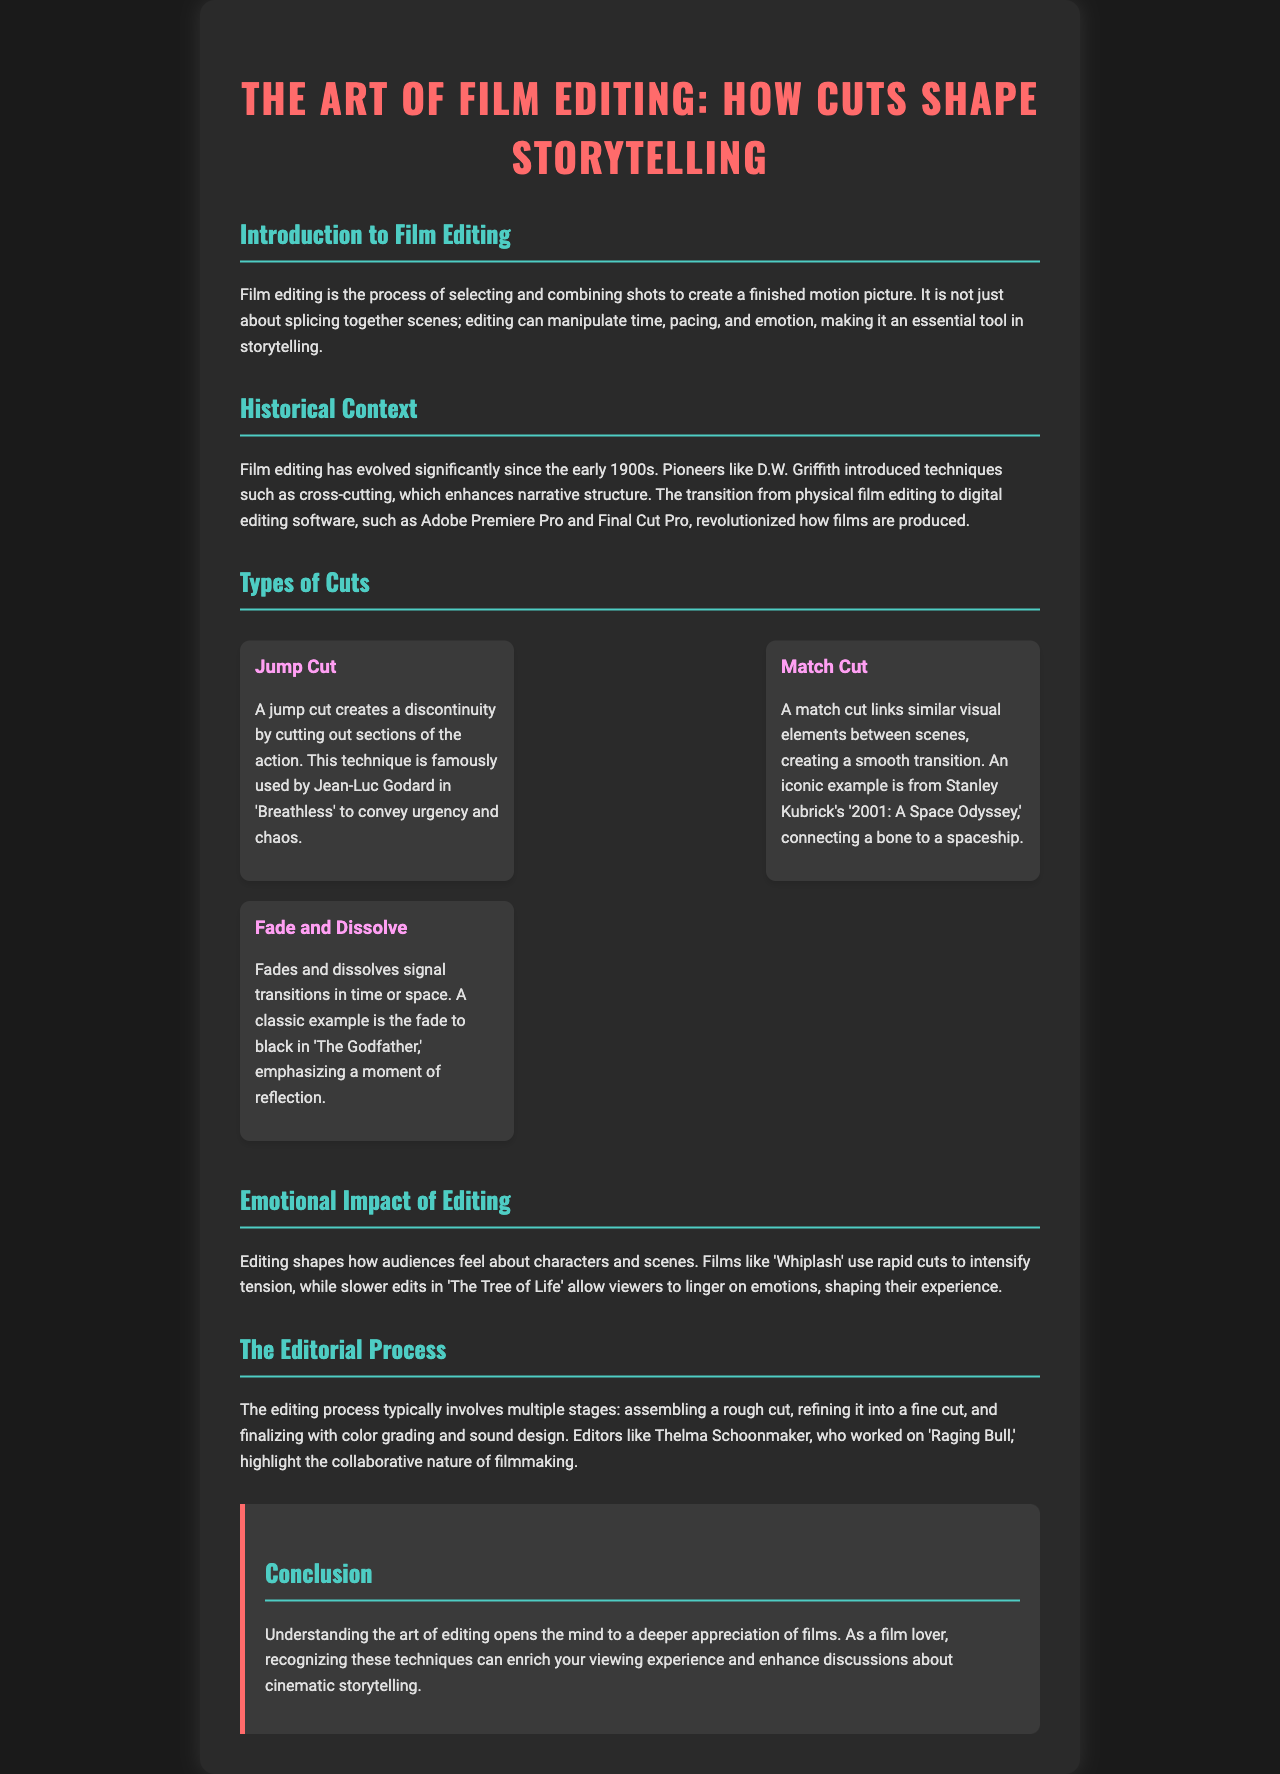what is film editing? The introduction section explains that film editing is the process of selecting and combining shots to create a finished motion picture.
Answer: selecting and combining shots who introduced cross-cutting techniques? The historical context section mentions D.W. Griffith as a pioneer who introduced cross-cutting techniques.
Answer: D.W. Griffith what is a common example of a jump cut? The types of cuts section describes the famous use of a jump cut by Jean-Luc Godard in 'Breathless.'
Answer: 'Breathless' which film is associated with a match cut linking a bone and a spaceship? The types of cuts section refers to Stanley Kubrick's '2001: A Space Odyssey' as an iconic example.
Answer: '2001: A Space Odyssey' what emotional effect do rapid cuts in 'Whiplash' create? The emotional impact of editing section states that rapid cuts are used to intensify tension in 'Whiplash.'
Answer: intensify tension how many stages are there in the editing process typically? The editorial process section outlines that the editing process typically involves multiple stages, though it does not specify a number.
Answer: multiple stages who highlighted the collaborative nature of filmmaking? The editorial process section mentions Thelma Schoonmaker, who worked on 'Raging Bull.'
Answer: Thelma Schoonmaker what do fades and dissolves signal in film editing? The types of cuts section indicates that fades and dissolves signal transitions in time or space.
Answer: transitions in time or space what is the overall purpose of understanding film editing? The conclusion section emphasizes that understanding the art of editing opens the mind to a deeper appreciation of films.
Answer: deeper appreciation of films 